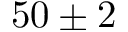<formula> <loc_0><loc_0><loc_500><loc_500>5 0 \pm 2</formula> 